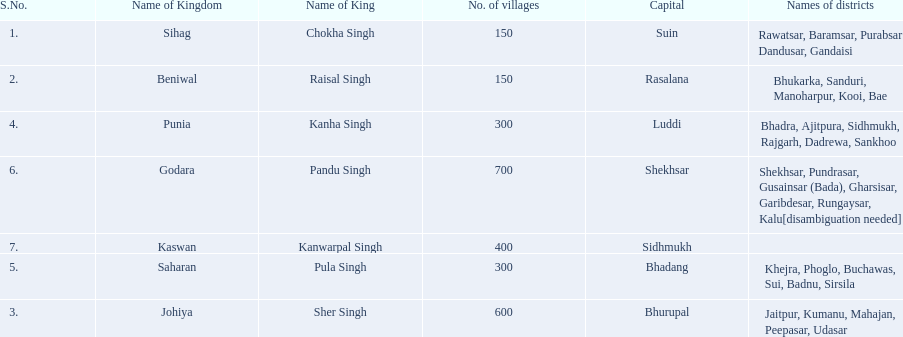He was the king of the sihag kingdom. Chokha Singh. 